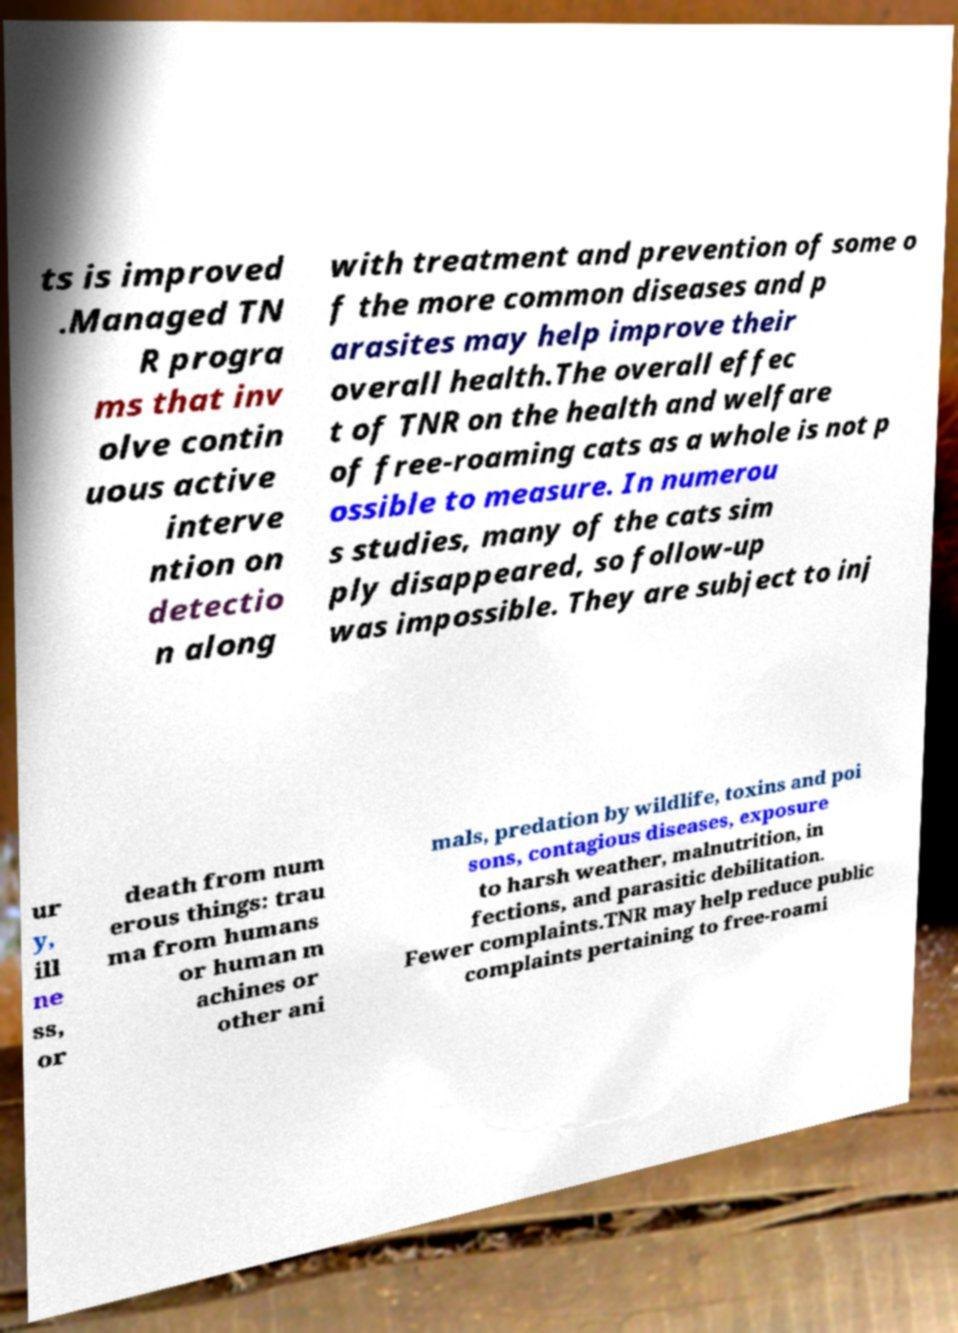Can you accurately transcribe the text from the provided image for me? ts is improved .Managed TN R progra ms that inv olve contin uous active interve ntion on detectio n along with treatment and prevention of some o f the more common diseases and p arasites may help improve their overall health.The overall effec t of TNR on the health and welfare of free-roaming cats as a whole is not p ossible to measure. In numerou s studies, many of the cats sim ply disappeared, so follow-up was impossible. They are subject to inj ur y, ill ne ss, or death from num erous things: trau ma from humans or human m achines or other ani mals, predation by wildlife, toxins and poi sons, contagious diseases, exposure to harsh weather, malnutrition, in fections, and parasitic debilitation. Fewer complaints.TNR may help reduce public complaints pertaining to free-roami 